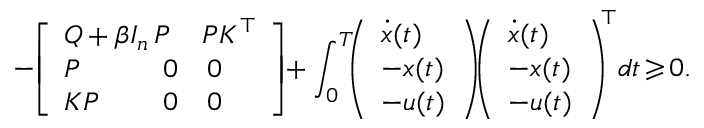Convert formula to latex. <formula><loc_0><loc_0><loc_500><loc_500>- \, \left [ \begin{array} { l l l } { Q + \beta I _ { n } \, } & { \, P \, } & { \, P K ^ { \top } } \\ { P } & { 0 } & { 0 } \\ { K P } & { 0 } & { 0 } \end{array} \right ] \, + \int _ { 0 } ^ { T } \, \left ( \begin{array} { l } { \dot { x } ( t ) } \\ { - x ( t ) } \\ { - u ( t ) } \end{array} \right ) \, \left ( \begin{array} { l } { \dot { x } ( t ) } \\ { - x ( t ) } \\ { - u ( t ) } \end{array} \right ) ^ { \, \top } \, d t \, \geqslant \, 0 .</formula> 